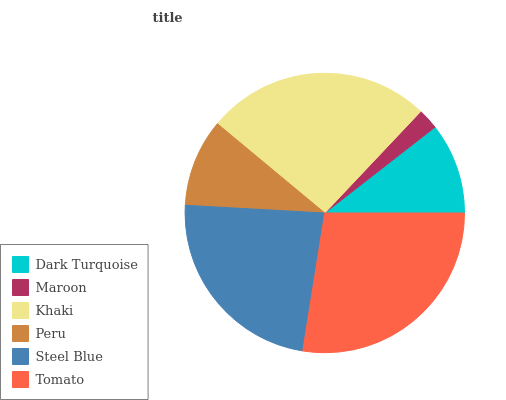Is Maroon the minimum?
Answer yes or no. Yes. Is Tomato the maximum?
Answer yes or no. Yes. Is Khaki the minimum?
Answer yes or no. No. Is Khaki the maximum?
Answer yes or no. No. Is Khaki greater than Maroon?
Answer yes or no. Yes. Is Maroon less than Khaki?
Answer yes or no. Yes. Is Maroon greater than Khaki?
Answer yes or no. No. Is Khaki less than Maroon?
Answer yes or no. No. Is Steel Blue the high median?
Answer yes or no. Yes. Is Dark Turquoise the low median?
Answer yes or no. Yes. Is Dark Turquoise the high median?
Answer yes or no. No. Is Peru the low median?
Answer yes or no. No. 